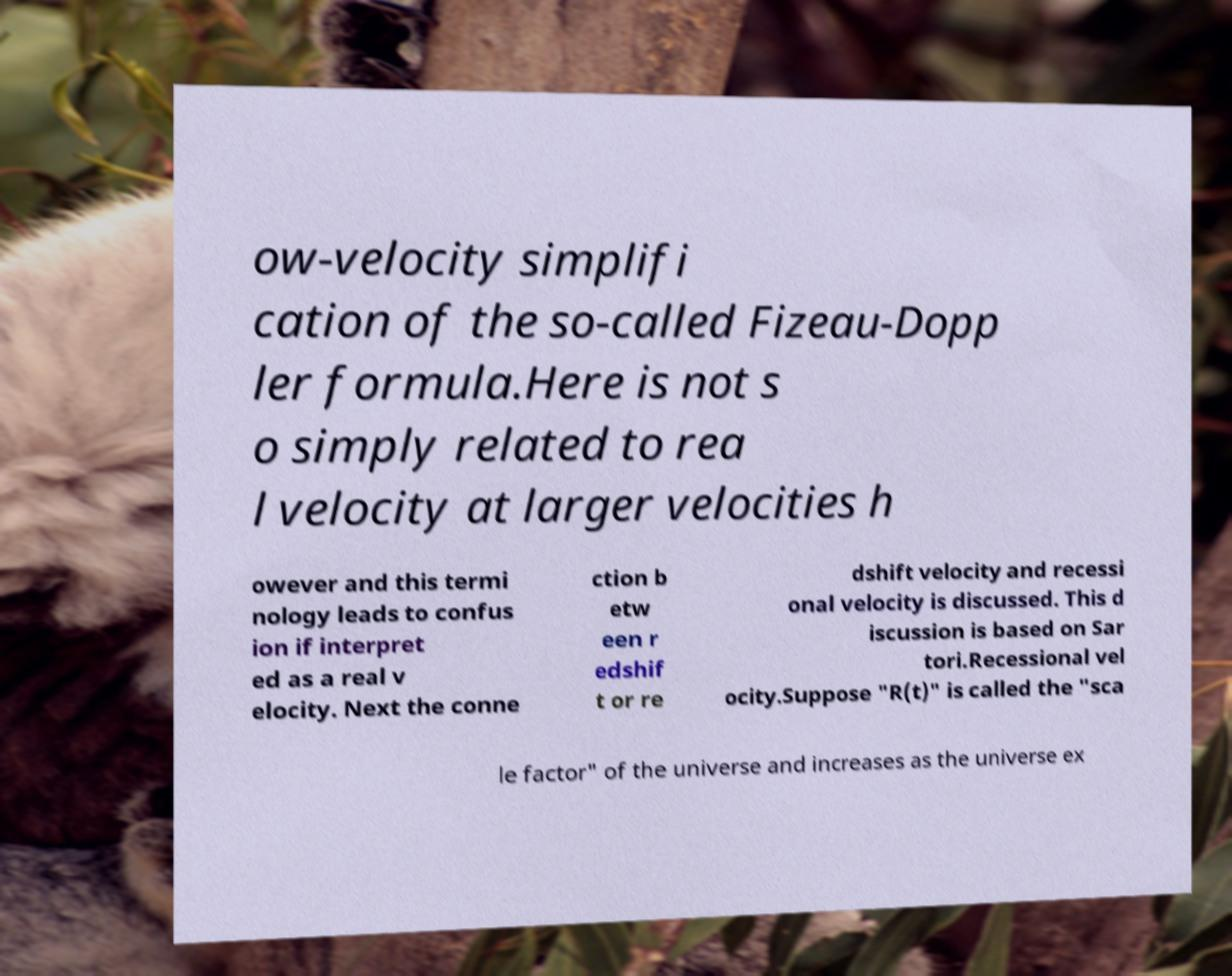There's text embedded in this image that I need extracted. Can you transcribe it verbatim? ow-velocity simplifi cation of the so-called Fizeau-Dopp ler formula.Here is not s o simply related to rea l velocity at larger velocities h owever and this termi nology leads to confus ion if interpret ed as a real v elocity. Next the conne ction b etw een r edshif t or re dshift velocity and recessi onal velocity is discussed. This d iscussion is based on Sar tori.Recessional vel ocity.Suppose "R(t)" is called the "sca le factor" of the universe and increases as the universe ex 